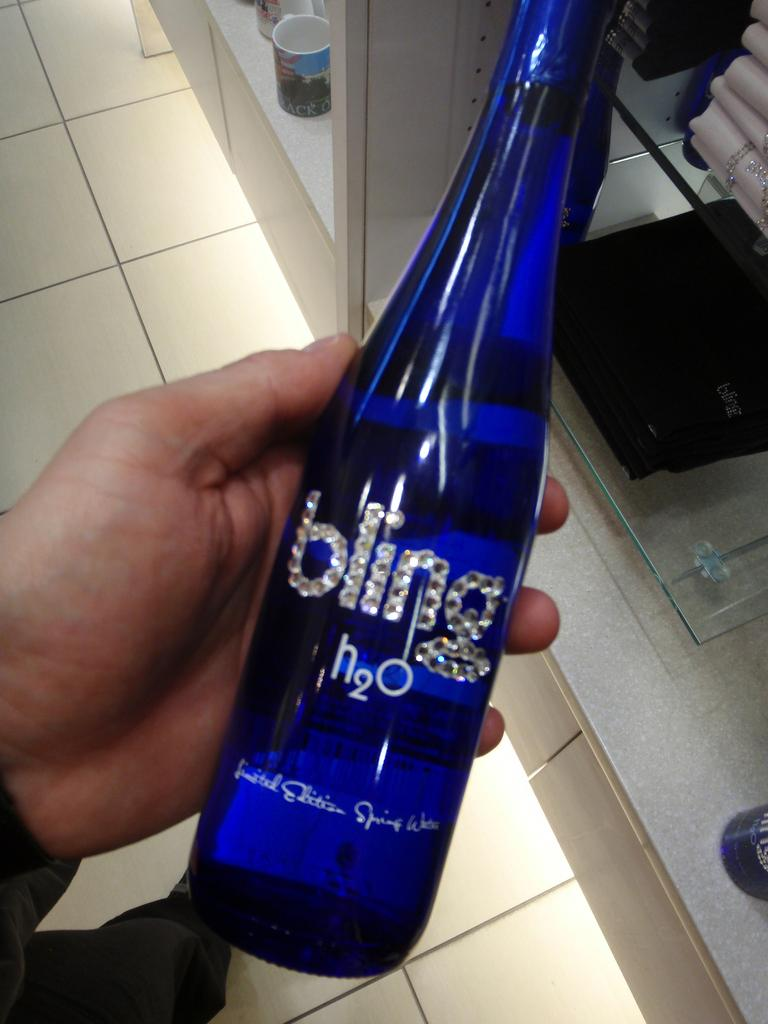What is being held by the man's hand on the left side of the image? There is a man's hand holding a bottle on the left side of the image. What color is the bottle being held? The bottle is blue in color. What can be seen on the shelves in the image? There are mugs placed on the shelves. Can you describe the shelves in the image? The shelves are part of the background and hold the mugs. Where is the downtown area in relation to the image? There is no reference to a downtown area in the image, so it cannot be determined from the image. 